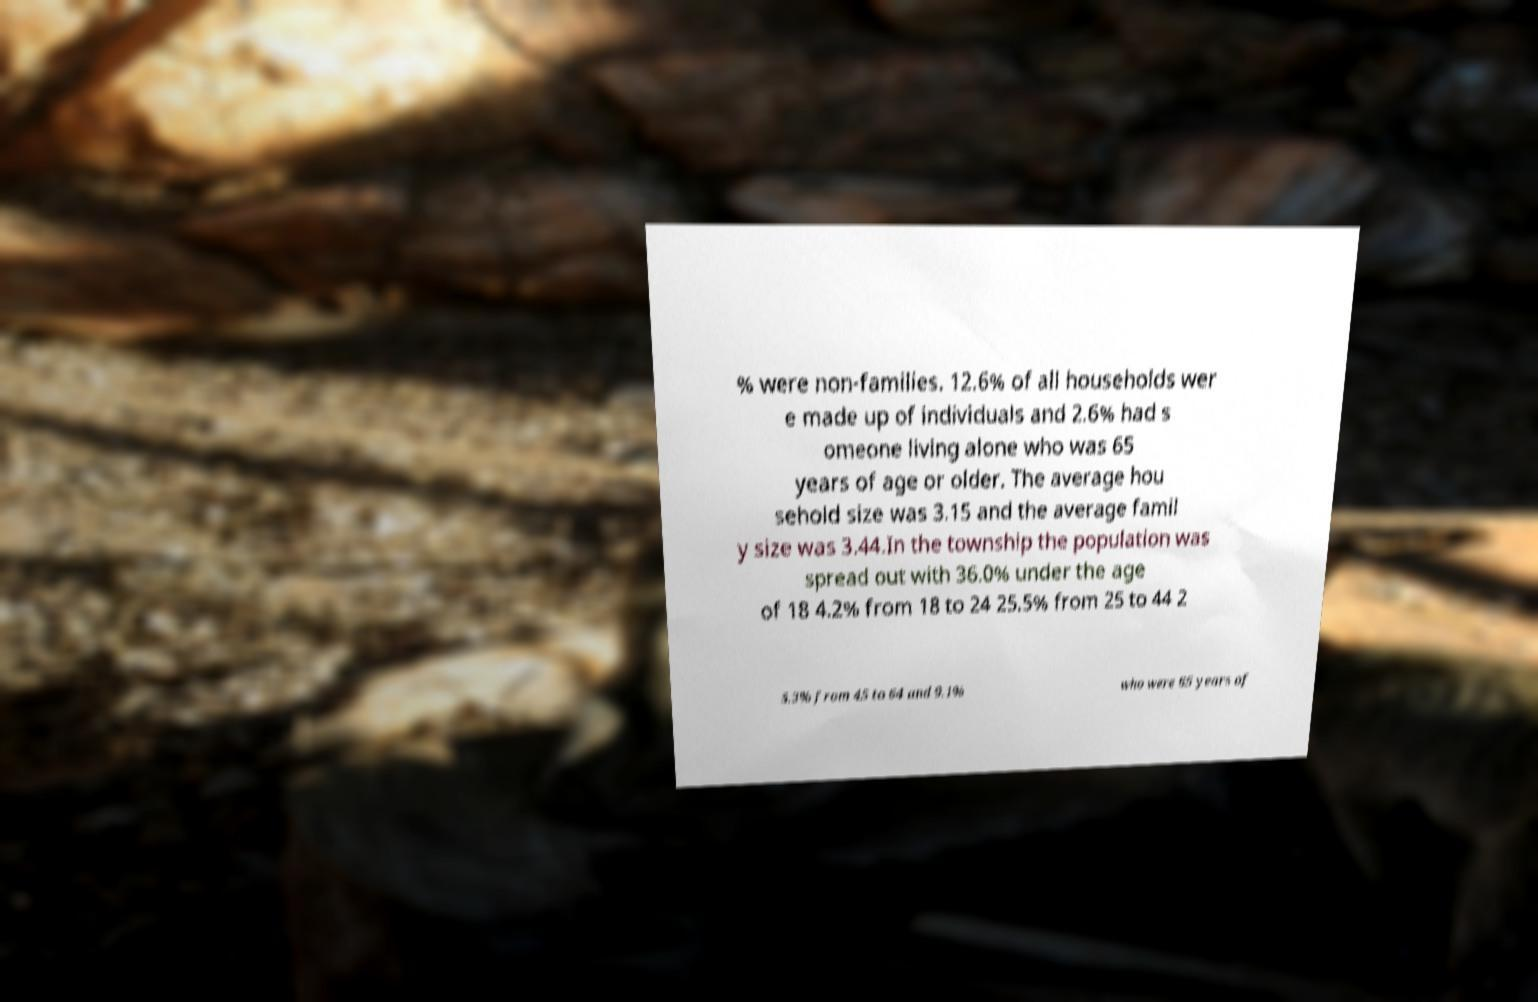I need the written content from this picture converted into text. Can you do that? % were non-families. 12.6% of all households wer e made up of individuals and 2.6% had s omeone living alone who was 65 years of age or older. The average hou sehold size was 3.15 and the average famil y size was 3.44.In the township the population was spread out with 36.0% under the age of 18 4.2% from 18 to 24 25.5% from 25 to 44 2 5.3% from 45 to 64 and 9.1% who were 65 years of 